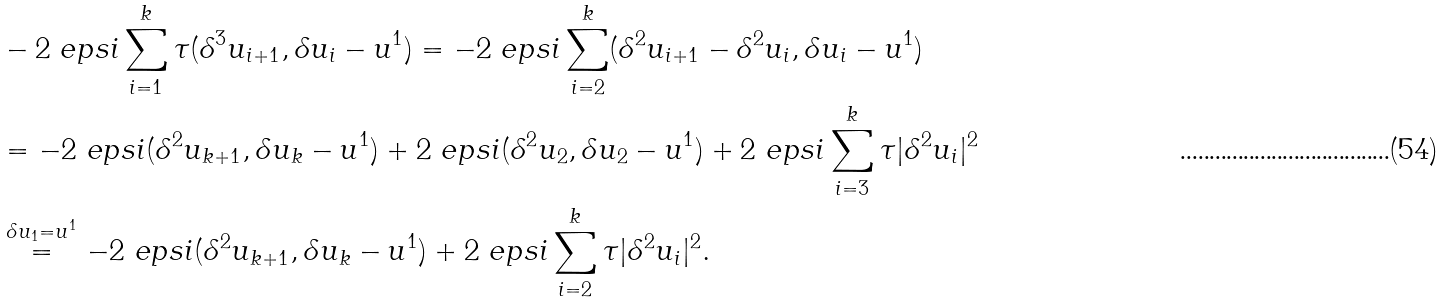Convert formula to latex. <formula><loc_0><loc_0><loc_500><loc_500>& - 2 \ e p s i \sum _ { i = 1 } ^ { k } \tau ( \delta ^ { 3 } u _ { i + 1 } , \delta u _ { i } - u ^ { 1 } ) = - 2 \ e p s i \sum _ { i = 2 } ^ { k } ( \delta ^ { 2 } u _ { i + 1 } - \delta ^ { 2 } u _ { i } , \delta u _ { i } - u ^ { 1 } ) \\ & = - 2 \ e p s i ( \delta ^ { 2 } u _ { k + 1 } , \delta u _ { k } - u ^ { 1 } ) + 2 \ e p s i ( \delta ^ { 2 } u _ { 2 } , \delta u _ { 2 } - u ^ { 1 } ) + 2 \ e p s i \sum _ { i = 3 } ^ { k } \tau | \delta ^ { 2 } u _ { i } | ^ { 2 } \\ & \stackrel { \delta u _ { 1 } = u ^ { 1 } } { = } - 2 \ e p s i ( \delta ^ { 2 } u _ { k + 1 } , \delta u _ { k } - u ^ { 1 } ) + 2 \ e p s i \sum _ { i = 2 } ^ { k } \tau | \delta ^ { 2 } u _ { i } | ^ { 2 } .</formula> 